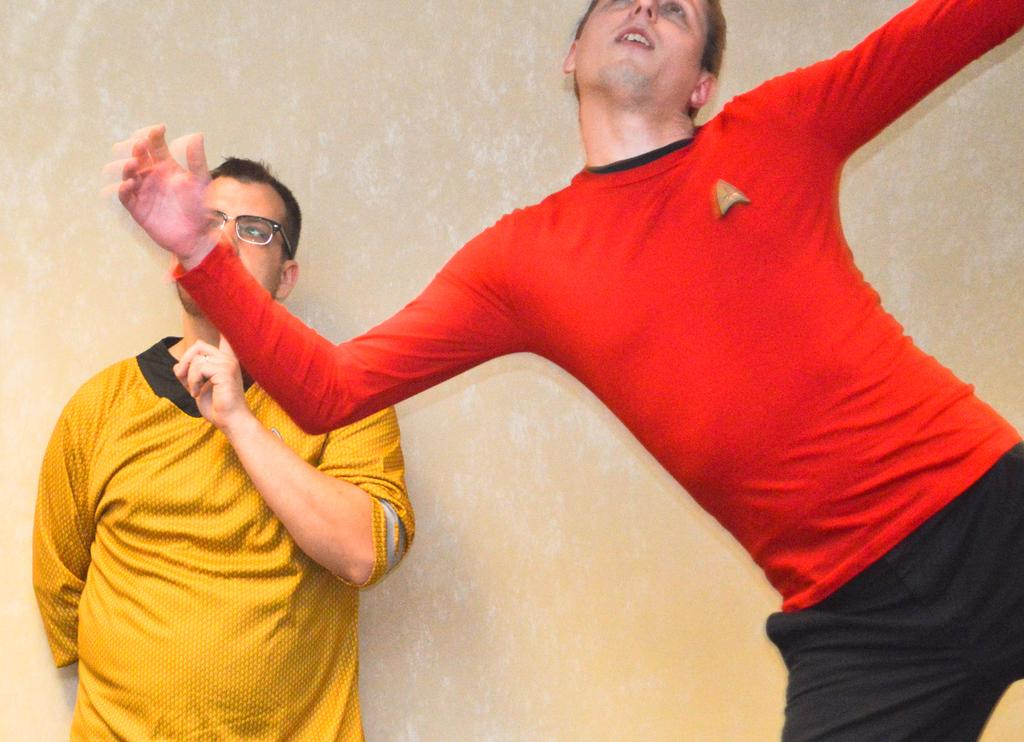How many people are in the image? There are two men standing in the image. Can you describe one of the men in the image? One of the men is wearing glasses. What can be seen in the background of the image? There is a wall visible in the background of the image. What type of afterthought is the toad having in the image? There is no toad present in the image, so it is not possible to answer that question. 